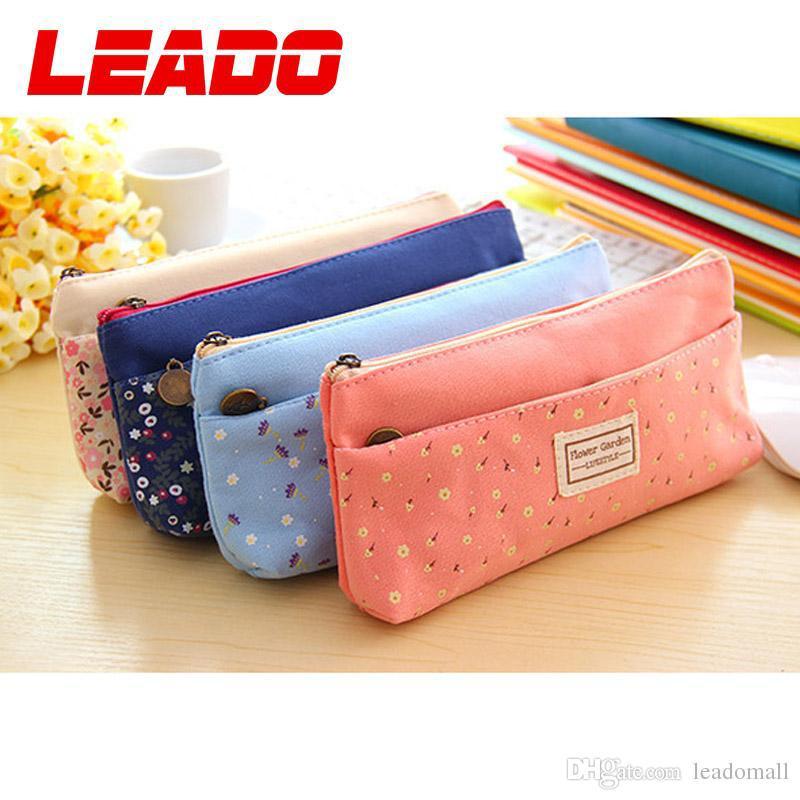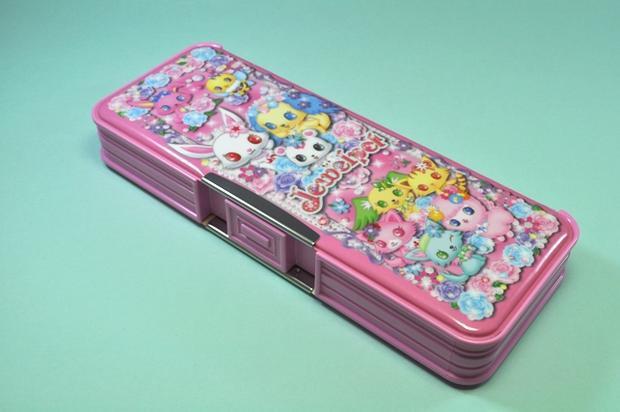The first image is the image on the left, the second image is the image on the right. Considering the images on both sides, is "Right image shows a pencil case decorated on top with a variety of cute animals, including a rabbit, dog, cat and bear." valid? Answer yes or no. Yes. The first image is the image on the left, the second image is the image on the right. For the images displayed, is the sentence "There are exactly two hard plastic pencil boxes that are both closed." factually correct? Answer yes or no. No. 